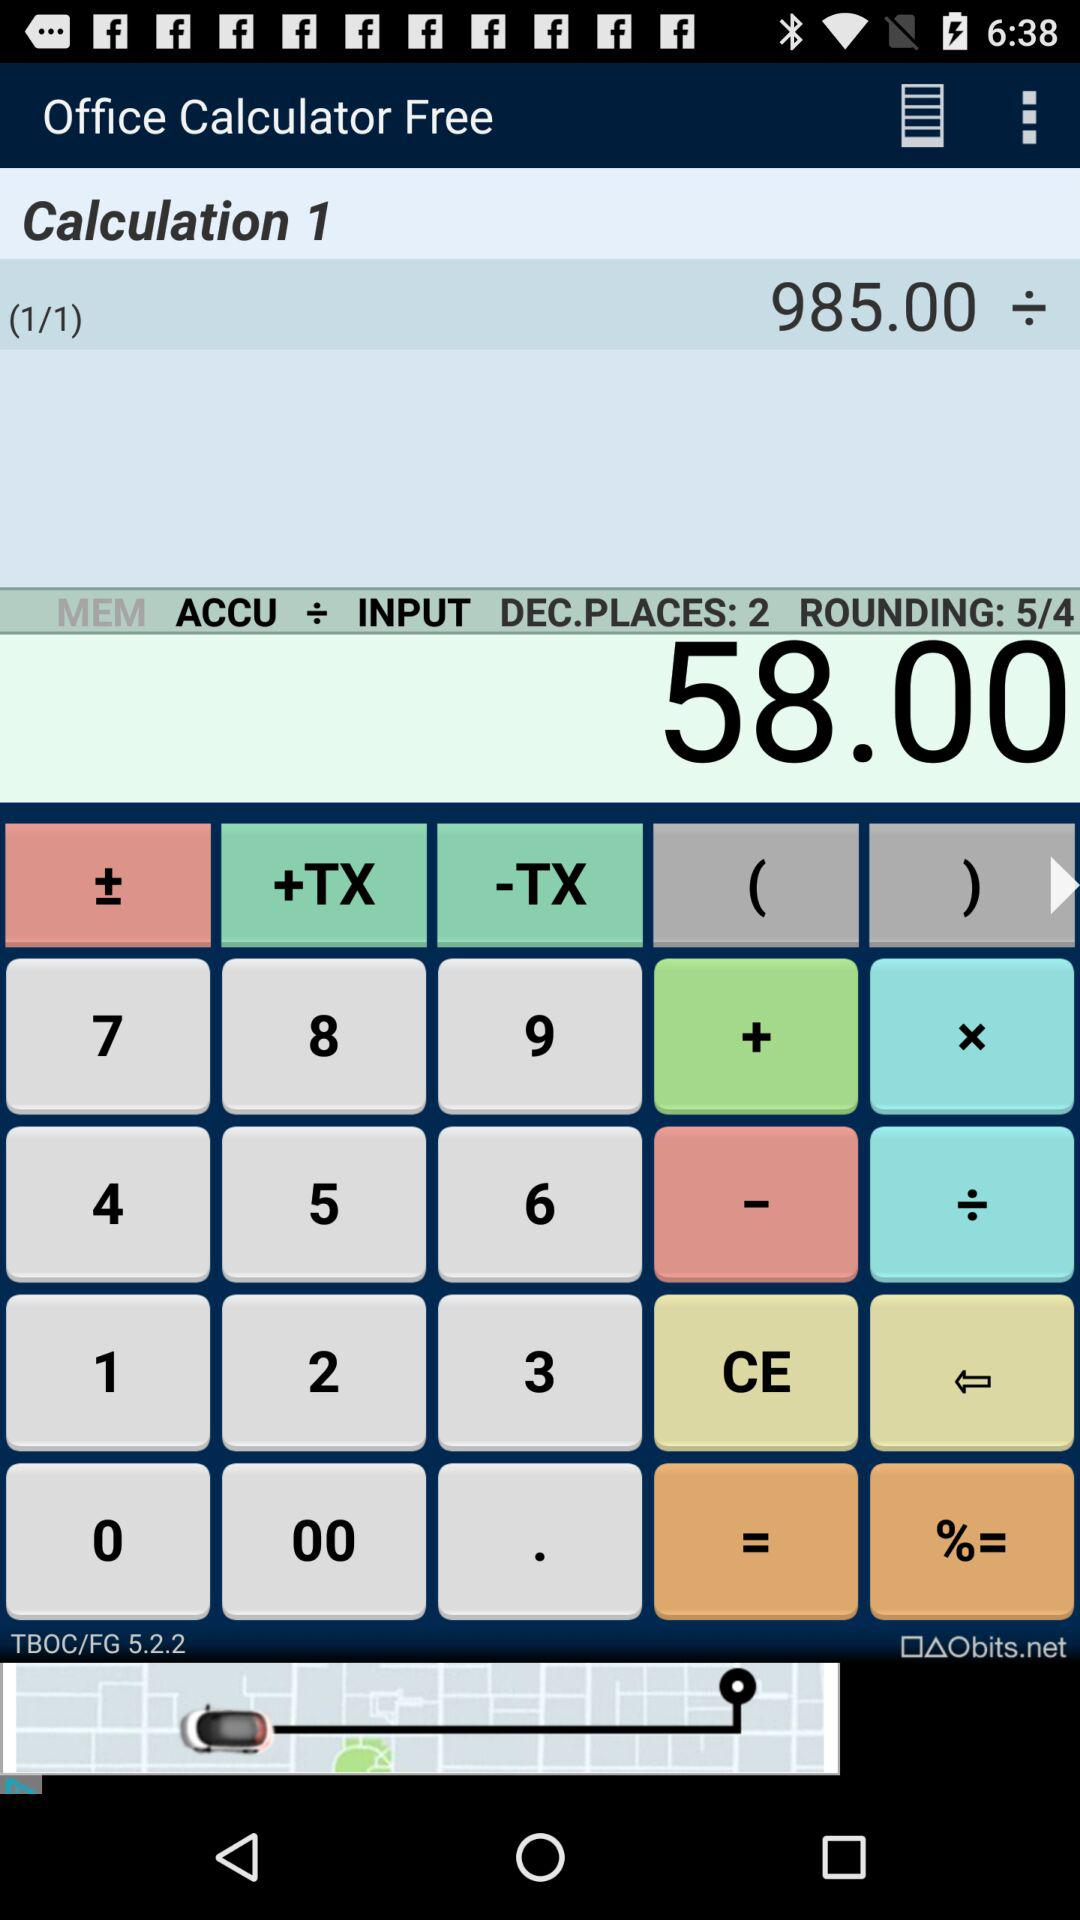What is the application name? The application name is "Office Calculator Free". 